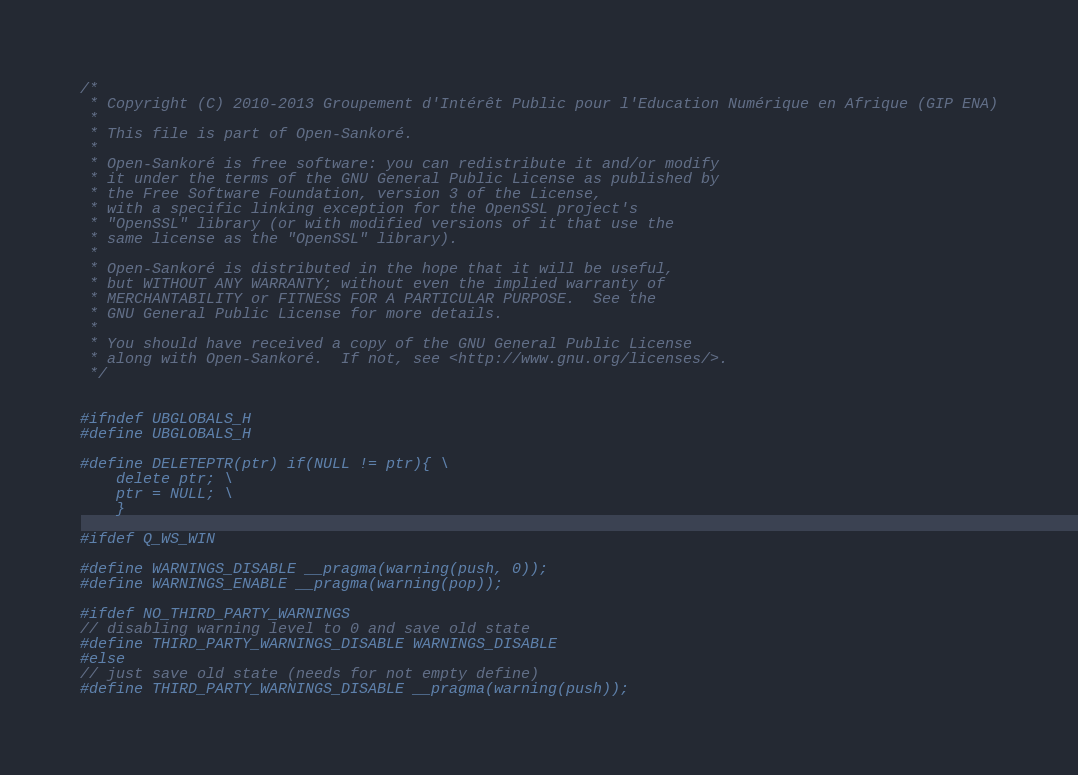<code> <loc_0><loc_0><loc_500><loc_500><_C_>/*
 * Copyright (C) 2010-2013 Groupement d'Intérêt Public pour l'Education Numérique en Afrique (GIP ENA)
 *
 * This file is part of Open-Sankoré.
 *
 * Open-Sankoré is free software: you can redistribute it and/or modify
 * it under the terms of the GNU General Public License as published by
 * the Free Software Foundation, version 3 of the License,
 * with a specific linking exception for the OpenSSL project's
 * "OpenSSL" library (or with modified versions of it that use the
 * same license as the "OpenSSL" library).
 *
 * Open-Sankoré is distributed in the hope that it will be useful,
 * but WITHOUT ANY WARRANTY; without even the implied warranty of
 * MERCHANTABILITY or FITNESS FOR A PARTICULAR PURPOSE.  See the
 * GNU General Public License for more details.
 *
 * You should have received a copy of the GNU General Public License
 * along with Open-Sankoré.  If not, see <http://www.gnu.org/licenses/>.
 */


#ifndef UBGLOBALS_H
#define UBGLOBALS_H

#define DELETEPTR(ptr) if(NULL != ptr){ \
    delete ptr; \
    ptr = NULL; \
    }

#ifdef Q_WS_WIN

#define WARNINGS_DISABLE __pragma(warning(push, 0));
#define WARNINGS_ENABLE __pragma(warning(pop));

#ifdef NO_THIRD_PARTY_WARNINGS
// disabling warning level to 0 and save old state
#define THIRD_PARTY_WARNINGS_DISABLE WARNINGS_DISABLE
#else
// just save old state (needs for not empty define)
#define THIRD_PARTY_WARNINGS_DISABLE __pragma(warning(push));</code> 